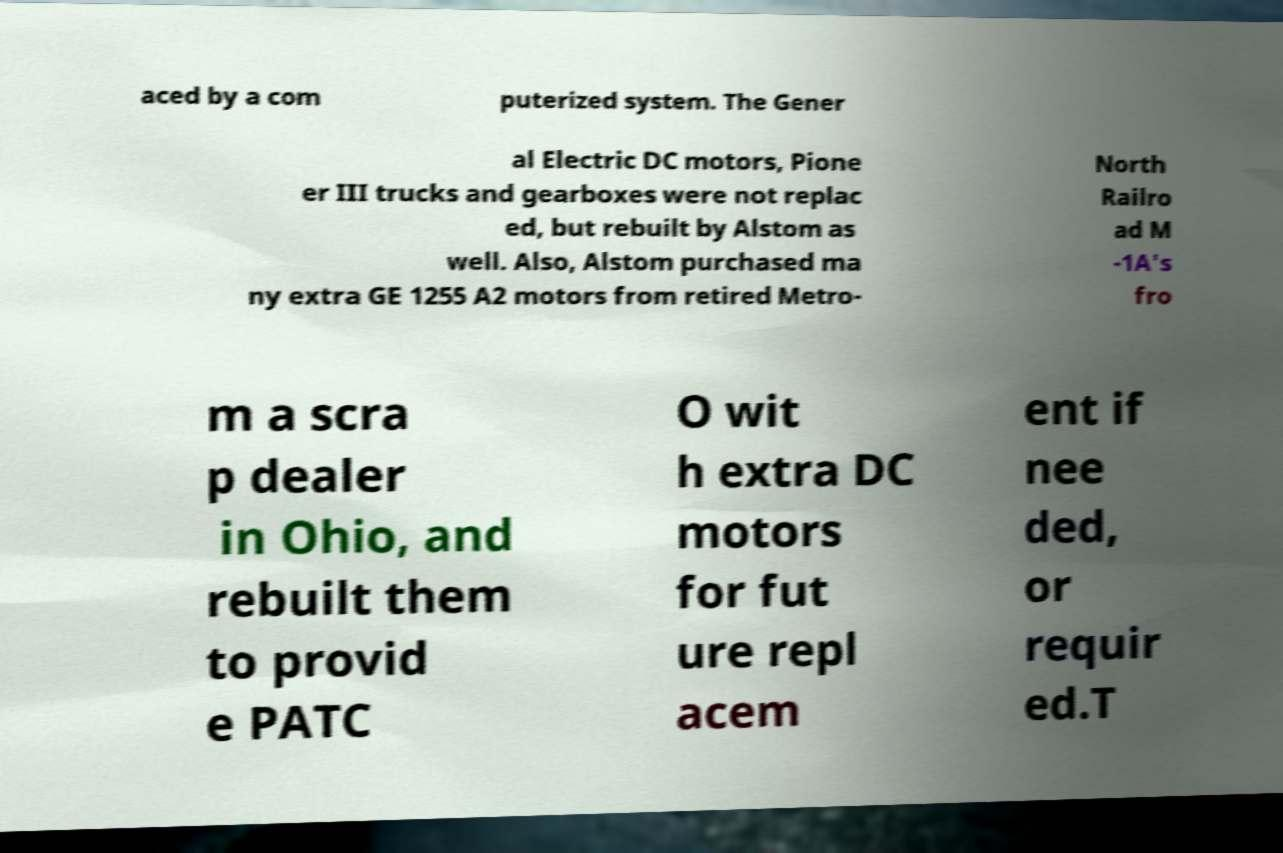Could you extract and type out the text from this image? aced by a com puterized system. The Gener al Electric DC motors, Pione er III trucks and gearboxes were not replac ed, but rebuilt by Alstom as well. Also, Alstom purchased ma ny extra GE 1255 A2 motors from retired Metro- North Railro ad M -1A's fro m a scra p dealer in Ohio, and rebuilt them to provid e PATC O wit h extra DC motors for fut ure repl acem ent if nee ded, or requir ed.T 